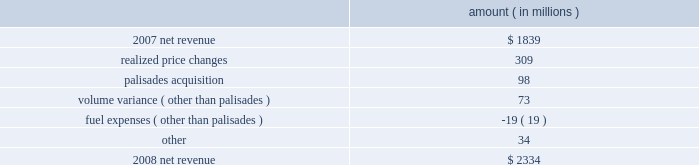Entergy corporation and subsidiaries management's financial discussion and analysis the purchased power capacity variance is primarily due to higher capacity charges .
A portion of the variance is due to the amortization of deferred capacity costs and is offset in base revenues due to base rate increases implemented to recover incremental deferred and ongoing purchased power capacity charges .
The volume/weather variance is primarily due to the effect of less favorable weather compared to the same period in 2007 and decreased electricity usage primarily during the unbilled sales period .
Hurricane gustav and hurricane ike , which hit the utility's service territories in september 2008 , contributed an estimated $ 46 million to the decrease in electricity usage .
Industrial sales were also depressed by the continuing effects of the hurricanes and , especially in the latter part of the year , because of the overall decline of the economy , leading to lower usage in the latter part of the year affecting both the large customer industrial segment as well as small and mid-sized industrial customers .
The decreases in electricity usage were partially offset by an increase in residential and commercial customer electricity usage that occurred during the periods of the year not affected by the hurricanes .
The retail electric price variance is primarily due to : an increase in the attala power plant costs recovered through the power management rider by entergy mississippi .
The net income effect of this recovery is limited to a portion representing an allowed return on equity with the remainder offset by attala power plant costs in other operation and maintenance expenses , depreciation expenses , and taxes other than income taxes ; a storm damage rider that became effective in october 2007 at entergy mississippi ; and an energy efficiency rider that became effective in november 2007 at entergy arkansas .
The establishment of the storm damage rider and the energy efficiency rider results in an increase in rider revenue and a corresponding increase in other operation and maintenance expense with no impact on net income .
The retail electric price variance was partially offset by : the absence of interim storm recoveries through the formula rate plans at entergy louisiana and entergy gulf states louisiana which ceased upon the act 55 financing of storm costs in the third quarter 2008 ; and a credit passed on to customers as a result of the act 55 storm cost financings .
Refer to "liquidity and capital resources - hurricane katrina and hurricane rita" below and note 2 to the financial statements for a discussion of the interim recovery of storm costs and the act 55 storm cost financings .
Non-utility nuclear following is an analysis of the change in net revenue comparing 2008 to 2007 .
Amount ( in millions ) .
As shown in the table above , net revenue for non-utility nuclear increased by $ 495 million , or 27% ( 27 % ) , in 2008 compared to 2007 primarily due to higher pricing in its contracts to sell power , additional production available from the acquisition of palisades in april 2007 , and fewer outage days .
In addition to the refueling outages shown in the .
In the analysis of the change in the net revenue between 2007 and 2008 what was the ratio of the revenues from realized price changes to the palisades acquisition? 
Computations: (309 / 98)
Answer: 3.15306. 